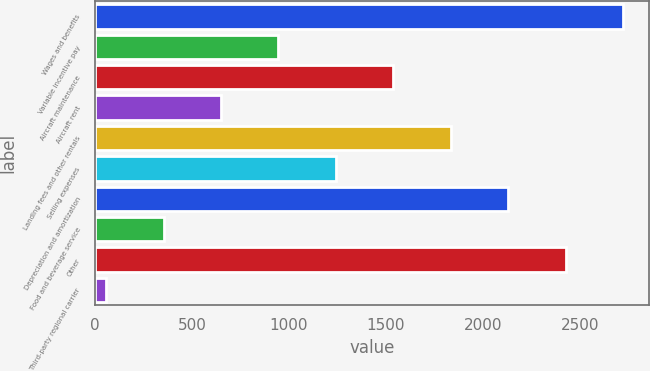Convert chart to OTSL. <chart><loc_0><loc_0><loc_500><loc_500><bar_chart><fcel>Wages and benefits<fcel>Variable incentive pay<fcel>Aircraft maintenance<fcel>Aircraft rent<fcel>Landing fees and other rentals<fcel>Selling expenses<fcel>Depreciation and amortization<fcel>Food and beverage service<fcel>Other<fcel>Third-party regional carrier<nl><fcel>2722<fcel>946<fcel>1538<fcel>650<fcel>1834<fcel>1242<fcel>2130<fcel>354<fcel>2426<fcel>58<nl></chart> 